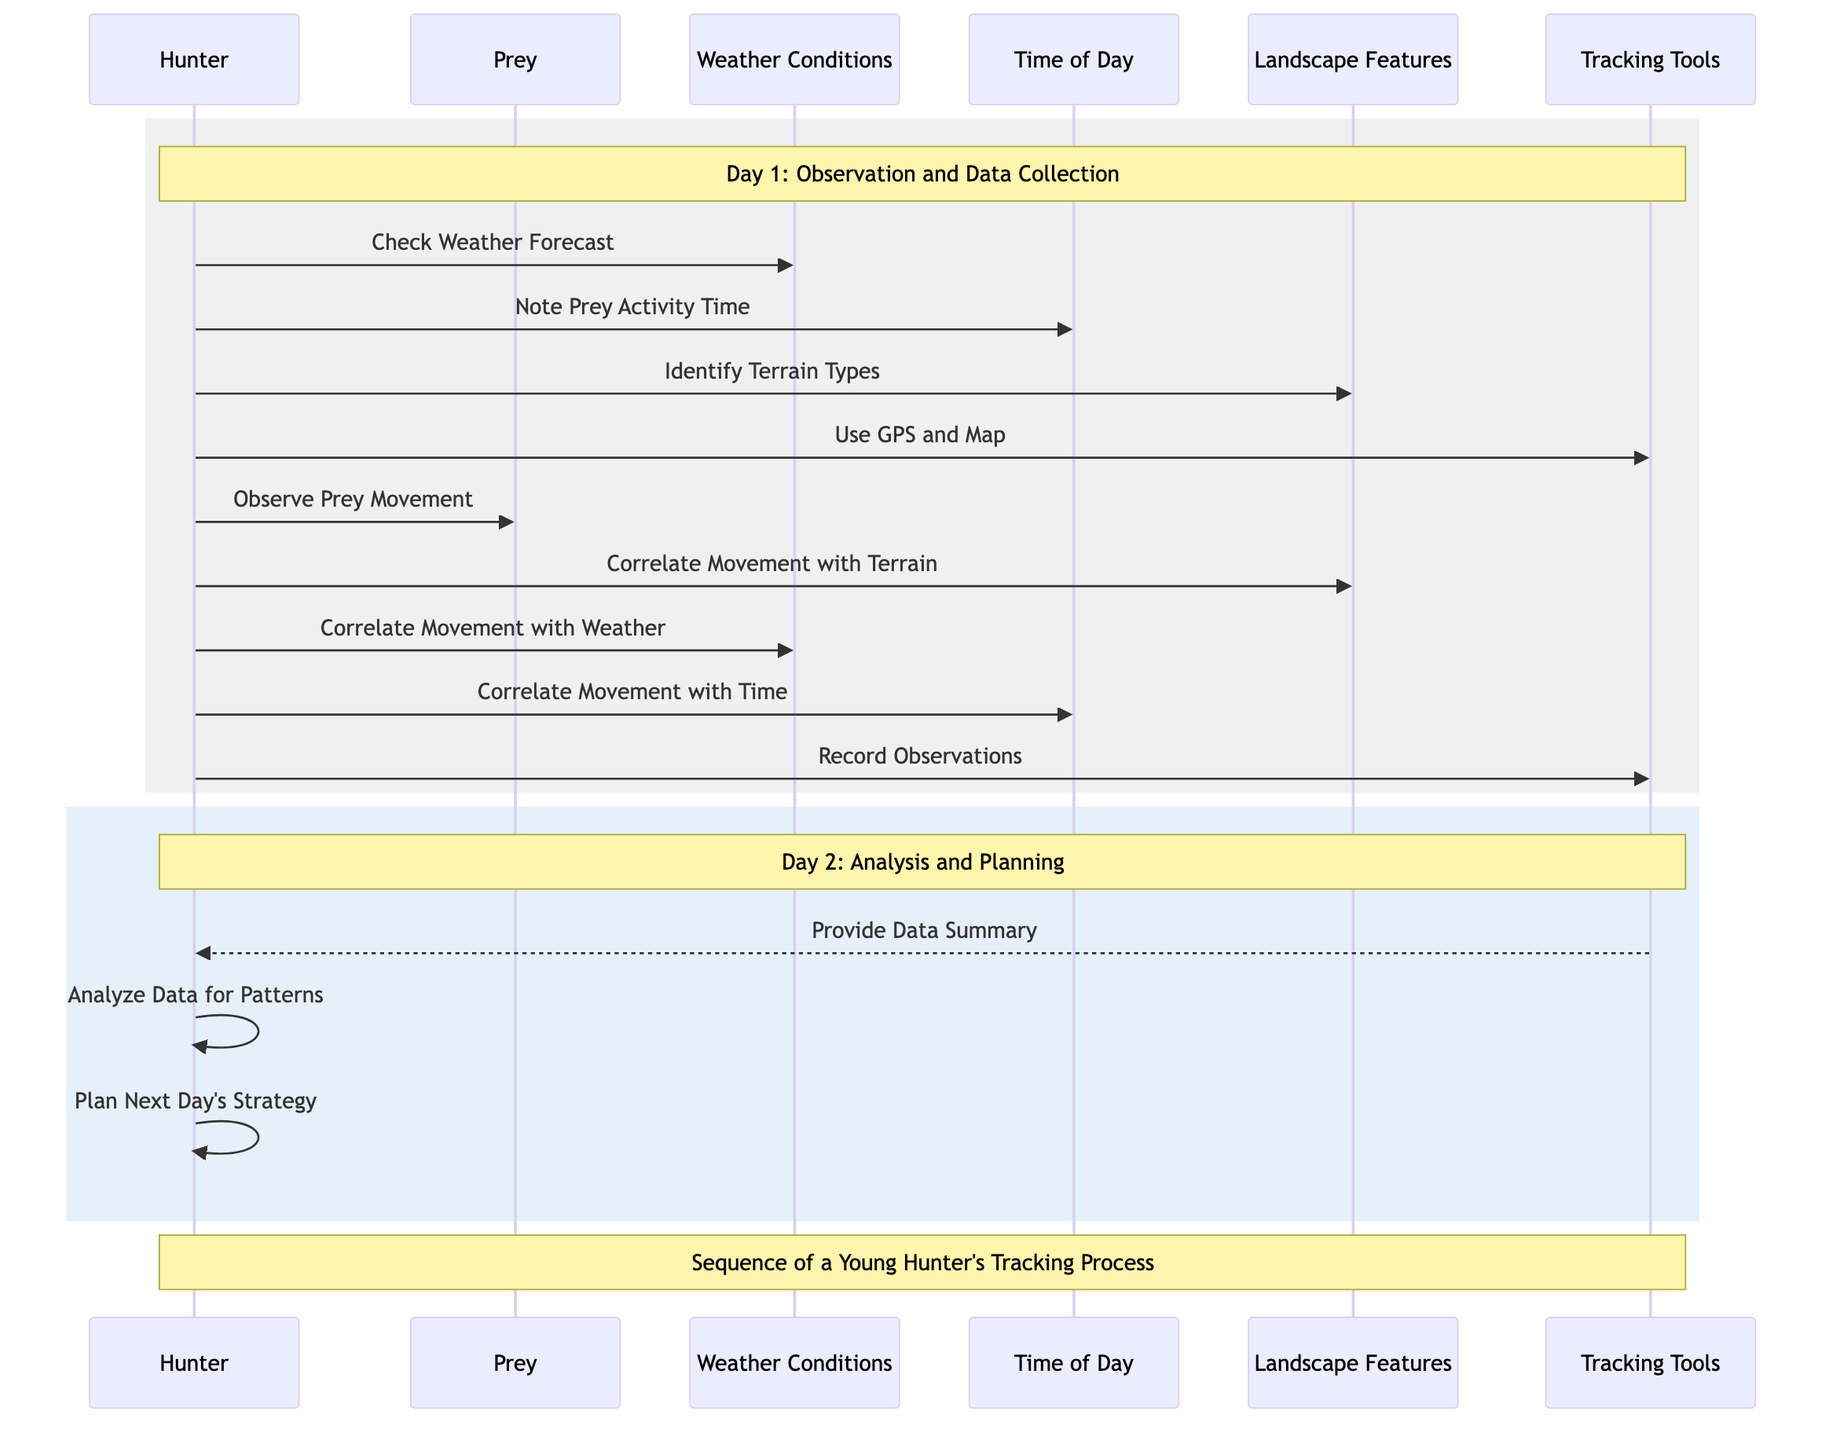What's the first action taken by the Hunter on Day 1? The first action in the sequence for Day 1 is the Hunter checking the weather forecast. This is clearly the first message sent from the Hunter to the Weather Conditions.
Answer: Check Weather Forecast How many participants are in the diagram? Counting the participants listed in the diagram, we have a total of six: Hunter, Prey, Weather Conditions, Time of Day, Landscape Features, and Tracking Tools. Therefore, the total number is six.
Answer: Six What is the last action recorded for Day 1? The last action for Day 1 is the Hunter recording observations, which is the final message sent within the Day 1 section in the diagram.
Answer: Record Observations Which participant provides the Data Summary? The Tracking Tools participant provides the Data Summary to the Hunter. This is a direct message showing the flow of information back to the Hunter.
Answer: Provide Data Summary What actions are performed by the Hunter on Day 2? On Day 2, the Hunter performs two actions: analyzing data for patterns and planning the next day's strategy. These are both self-referential actions indicating the Hunter's internal processing.
Answer: Analyze Data for Patterns, Plan Next Day's Strategy What is the interaction between Hunter and Time of Day on Day 1? The Hunter interacts with Time of Day by noting the prey activity time and then correlating it with movement, indicating a two-step interaction focused on understanding prey behavior relative to time.
Answer: Note Prey Activity Time, Correlate Movement with Time How many actions involve the Landscape Features? There are three actions involving the Landscape Features: identifying terrain types, correlating movement with terrain, and thus there are a total of three distinct interactions.
Answer: Three What does the Weather Conditions contribute to the Hunter's analysis? The Weather Conditions contribute to the analysis by having the Hunter correlate movement with weather, which is essential for understanding any patterns influenced by climate.
Answer: Correlate Movement with Weather What can be inferred about the importance of Tracking Tools? The Tracking Tools are crucial as they both assist in the hunting process and summarize the data collected over the two days, thus highlighting their role in facilitating tracking and analysis.
Answer: Essential for tracking and analysis 